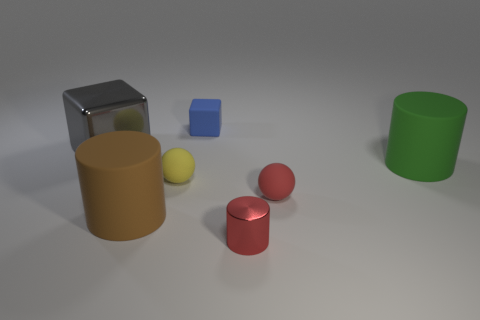Add 2 brown metallic blocks. How many objects exist? 9 Subtract all cylinders. How many objects are left? 4 Add 5 blocks. How many blocks are left? 7 Add 4 brown cylinders. How many brown cylinders exist? 5 Subtract 1 green cylinders. How many objects are left? 6 Subtract all yellow balls. Subtract all brown cylinders. How many objects are left? 5 